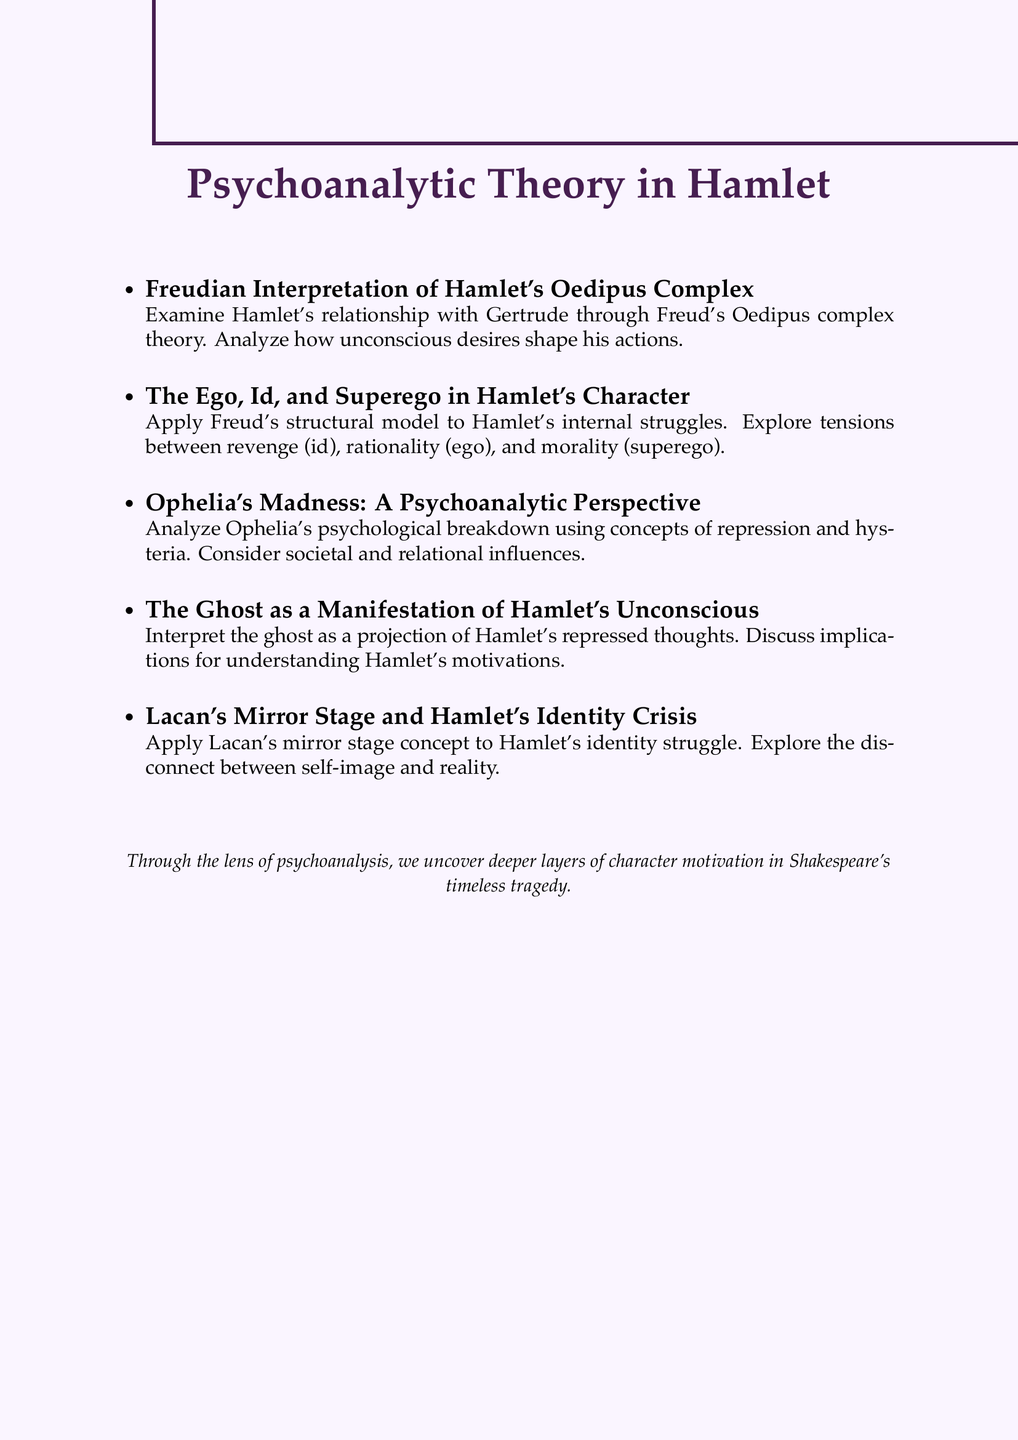What is the first topic discussed in the document? The first topic listed is "Freudian Interpretation of Hamlet's Oedipus Complex."
Answer: Freudian Interpretation of Hamlet's Oedipus Complex How many main topics are covered in the document? There are five main topics discussed in the document.
Answer: 5 What psychoanalytic concept is applied to Ophelia's situation? The concepts of repression and hysteria are applied to analyze Ophelia's madness.
Answer: repression and hysteria Who is analyzed in relation to the Oedipus complex? Hamlet's relationship with his mother, Gertrude, is analyzed in relation to the Oedipus complex.
Answer: Gertrude What does Lacan's mirror stage relate to in Hamlet? It relates to Hamlet's struggle with his identity and role.
Answer: identity and role Which character's motivations are viewed through the lens of repressed thoughts? The motivations of Hamlet are viewed through the lens of repressed thoughts associated with the ghost.
Answer: Hamlet What drives the plot according to the Ego, Id, and Superego analysis? The tension between Hamlet's id (desire for revenge), ego (rational thinking), and superego (moral conscience) drives the plot.
Answer: tension between id, ego, and superego What is the underlying theme of the document? The underlying theme is uncovering deeper layers of character motivation in Hamlet through psychoanalysis.
Answer: deeper layers of character motivation 